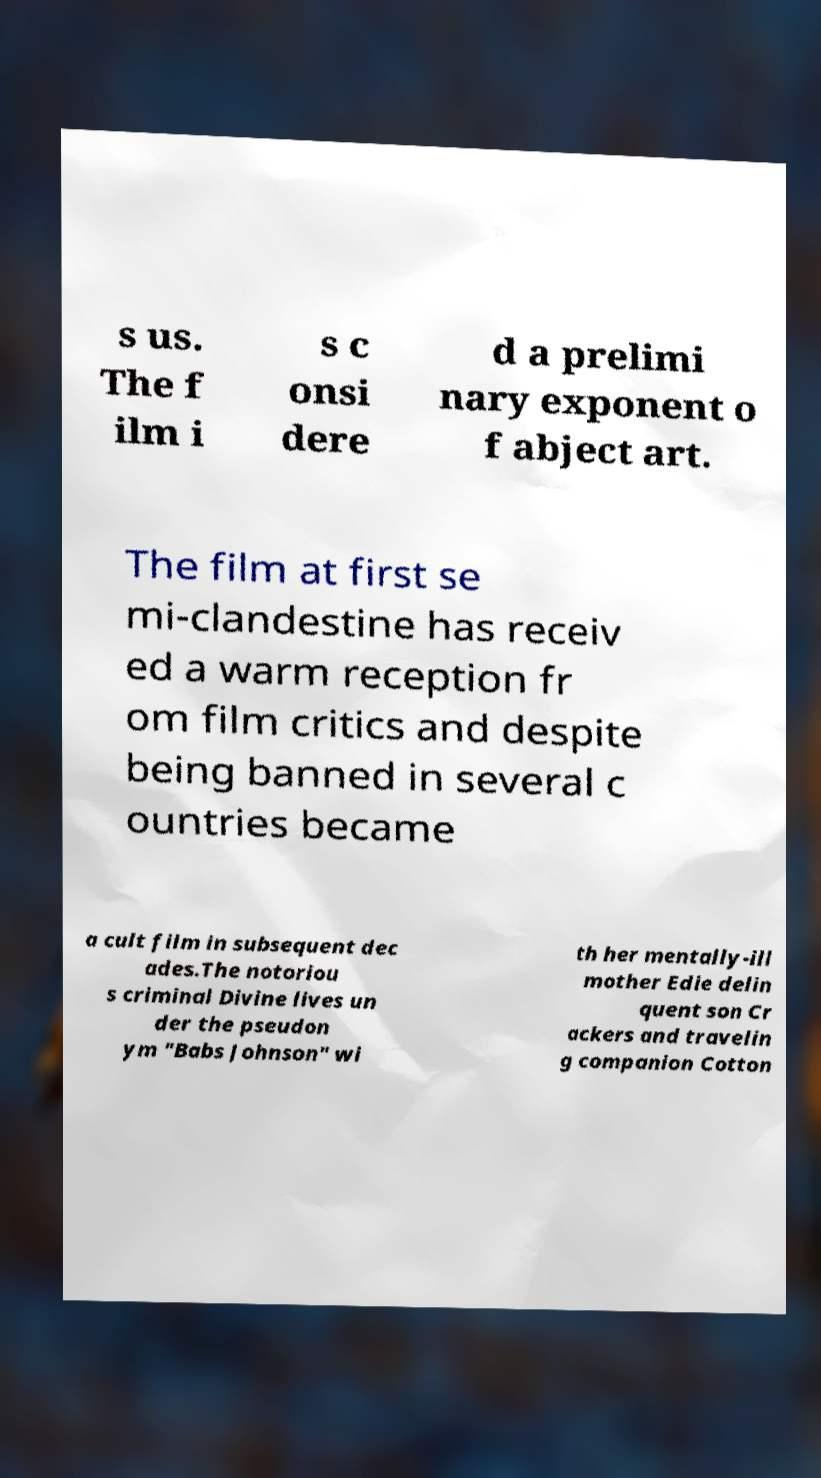Please read and relay the text visible in this image. What does it say? s us. The f ilm i s c onsi dere d a prelimi nary exponent o f abject art. The film at first se mi-clandestine has receiv ed a warm reception fr om film critics and despite being banned in several c ountries became a cult film in subsequent dec ades.The notoriou s criminal Divine lives un der the pseudon ym "Babs Johnson" wi th her mentally-ill mother Edie delin quent son Cr ackers and travelin g companion Cotton 